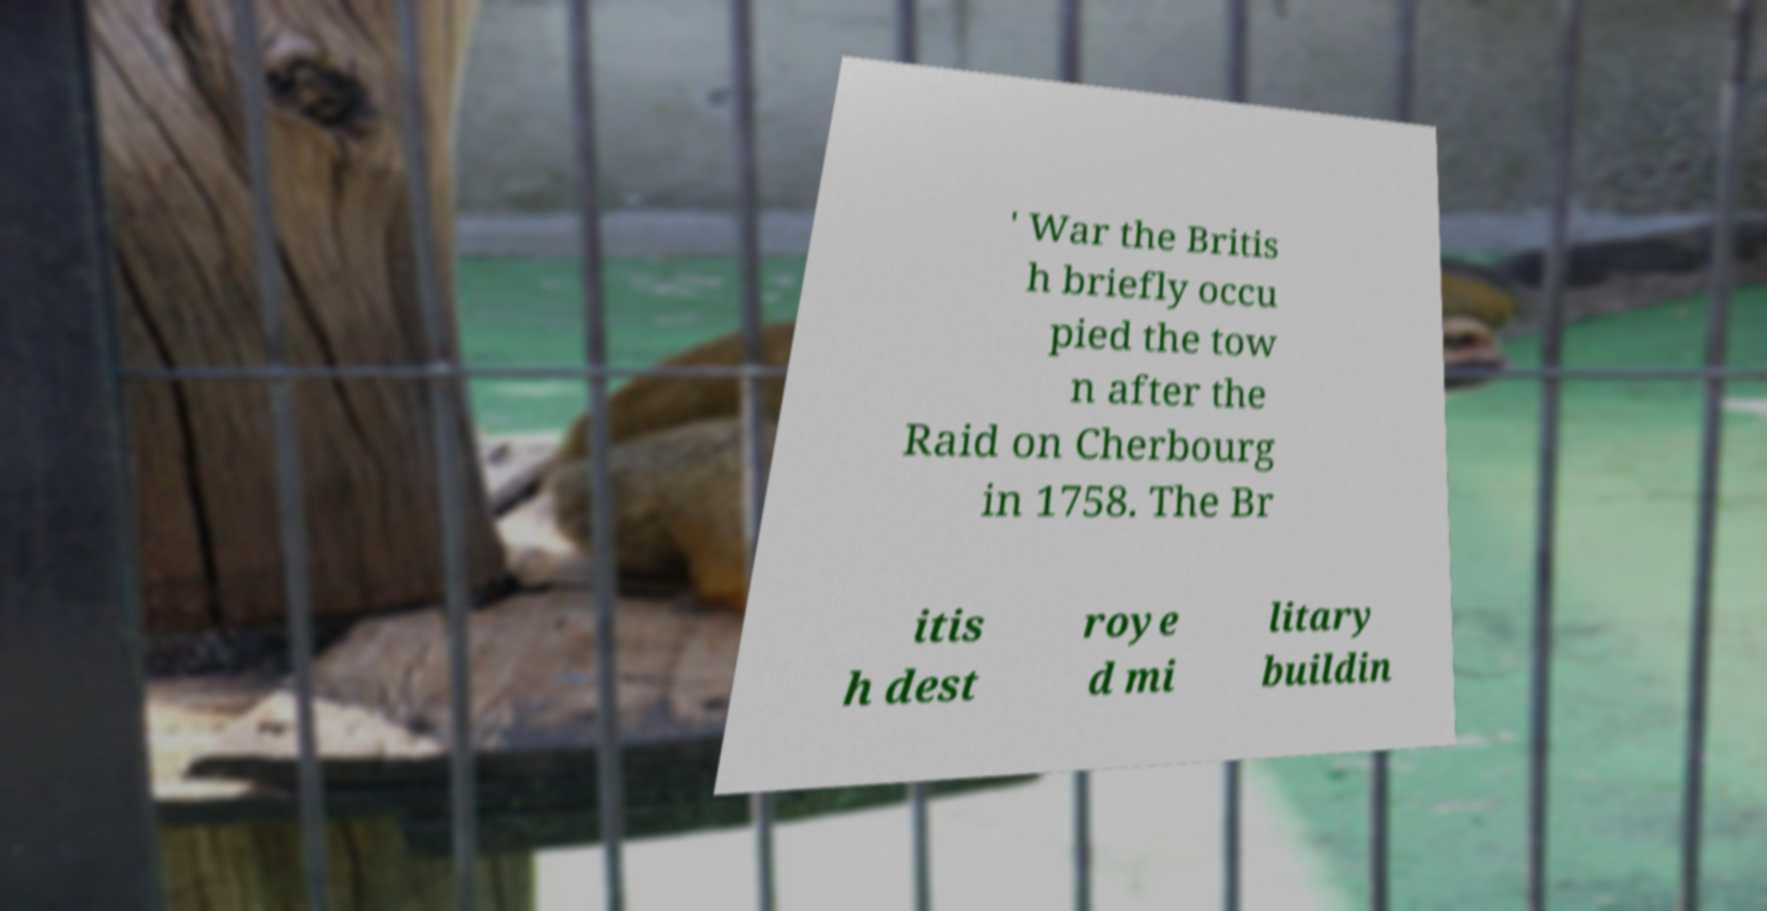Please identify and transcribe the text found in this image. ' War the Britis h briefly occu pied the tow n after the Raid on Cherbourg in 1758. The Br itis h dest roye d mi litary buildin 